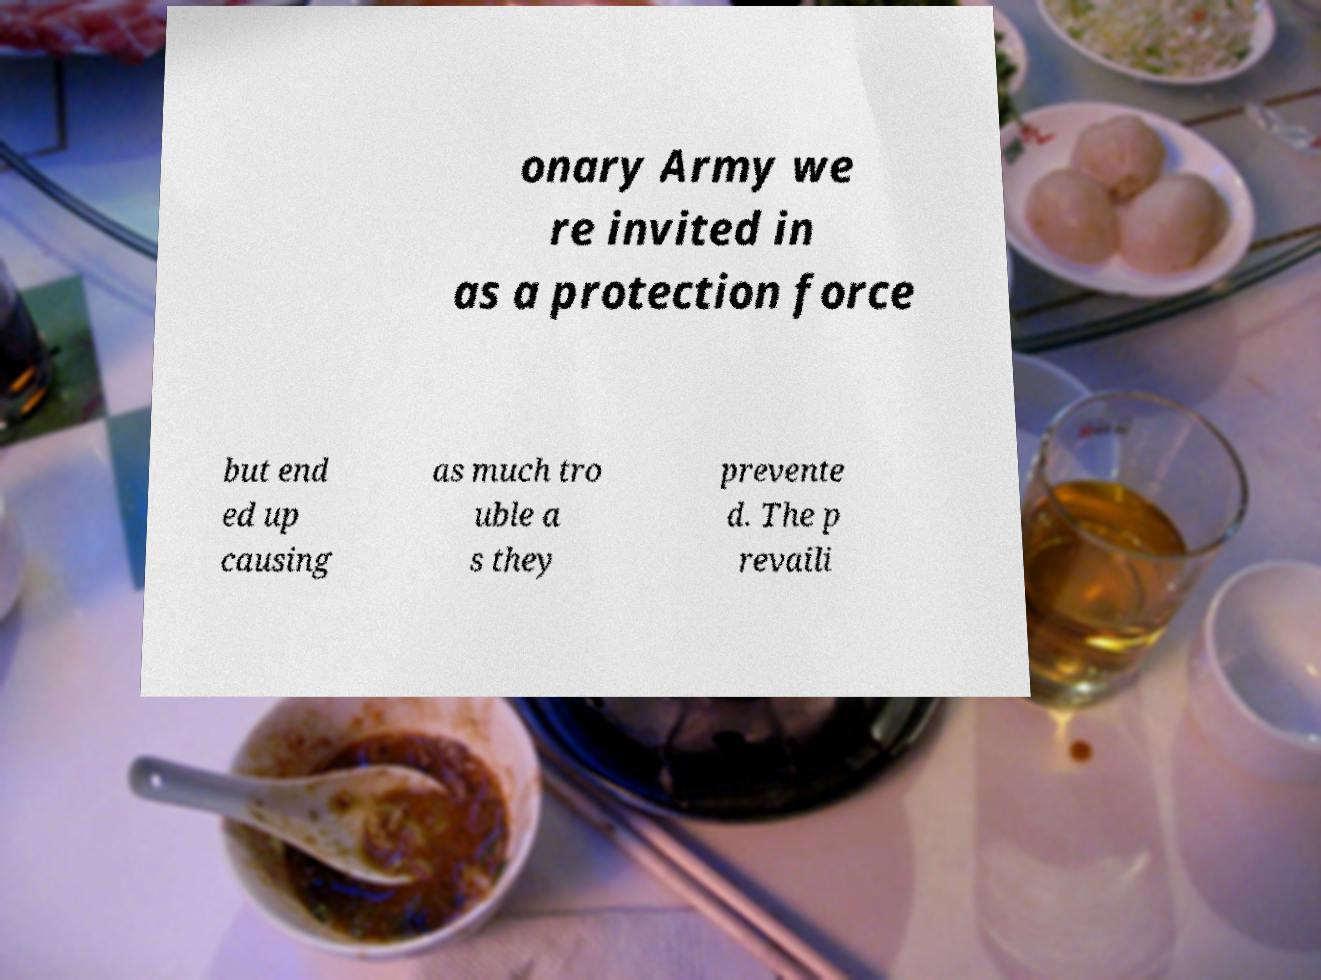Could you extract and type out the text from this image? onary Army we re invited in as a protection force but end ed up causing as much tro uble a s they prevente d. The p revaili 